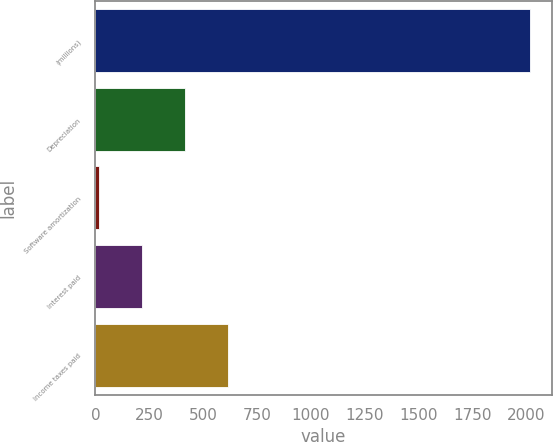Convert chart. <chart><loc_0><loc_0><loc_500><loc_500><bar_chart><fcel>(millions)<fcel>Depreciation<fcel>Software amortization<fcel>Interest paid<fcel>Income taxes paid<nl><fcel>2017<fcel>415<fcel>14.5<fcel>214.75<fcel>615.25<nl></chart> 